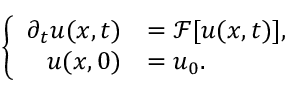Convert formula to latex. <formula><loc_0><loc_0><loc_500><loc_500>\left \{ \begin{array} { r l } { \partial _ { t } u ( x , t ) } & { = \mathcal { F } [ u ( x , t ) ] , } \\ { u ( x , 0 ) } & { = u _ { 0 } . } \end{array}</formula> 